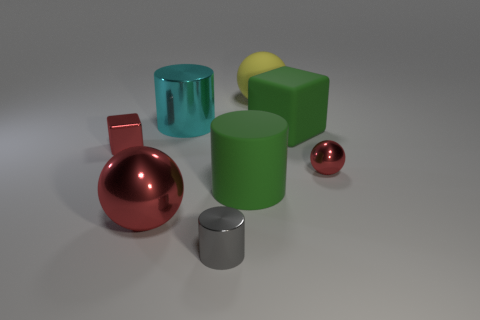Are there any brown cylinders that have the same size as the yellow thing?
Ensure brevity in your answer.  No. How many green objects are the same shape as the gray metallic thing?
Your response must be concise. 1. Are there the same number of rubber balls in front of the cyan metal cylinder and tiny spheres behind the big matte sphere?
Your answer should be very brief. Yes. Is there a cyan metallic cylinder?
Keep it short and to the point. Yes. What size is the cube that is on the left side of the red ball that is on the left side of the big thing behind the cyan thing?
Provide a short and direct response. Small. The gray metal object that is the same size as the red cube is what shape?
Keep it short and to the point. Cylinder. Is there anything else that has the same material as the tiny red sphere?
Ensure brevity in your answer.  Yes. How many objects are either tiny things behind the small gray cylinder or large red metal balls?
Provide a short and direct response. 3. Are there any small gray cylinders behind the big green rubber object behind the small red metallic cube that is in front of the big cyan shiny cylinder?
Your response must be concise. No. What number of tiny blue metallic things are there?
Your response must be concise. 0. 